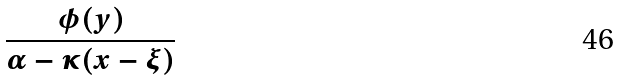<formula> <loc_0><loc_0><loc_500><loc_500>\frac { \phi ( y ) } { \alpha - \kappa ( x - \xi ) }</formula> 